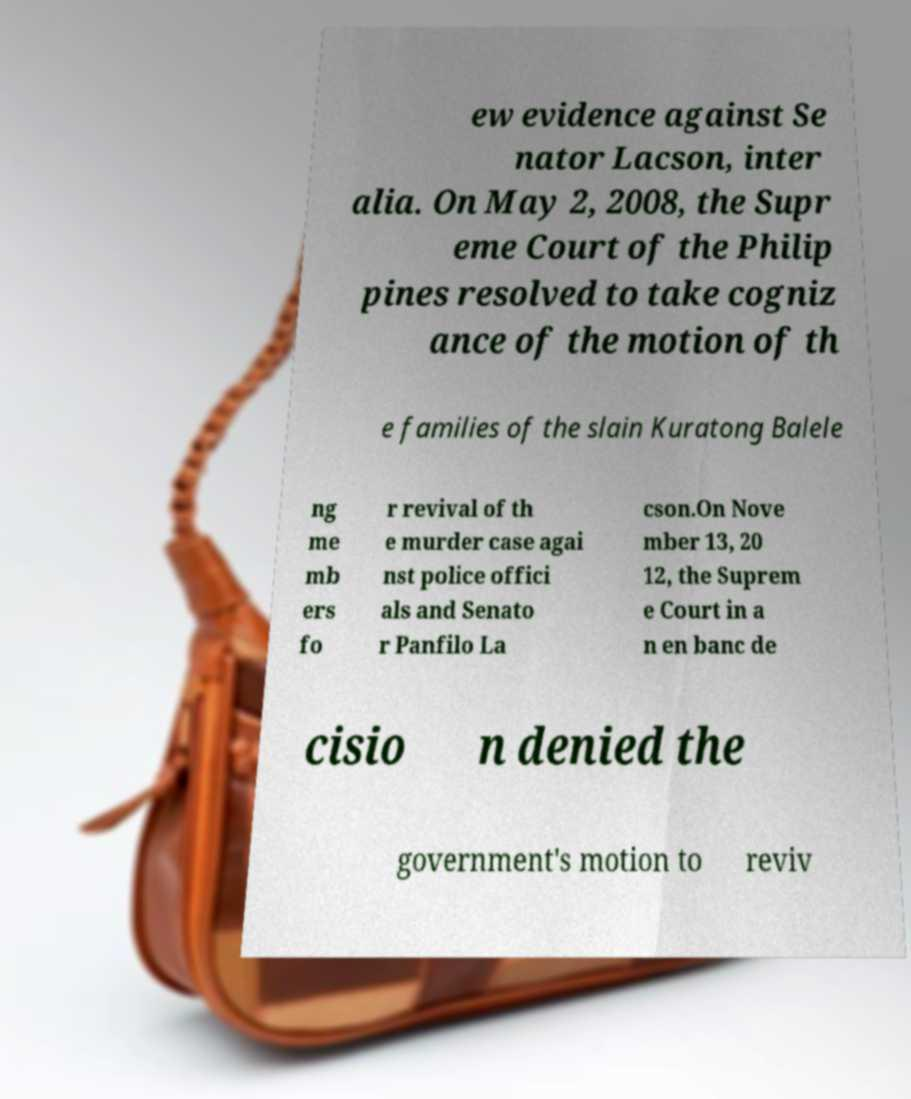Could you extract and type out the text from this image? ew evidence against Se nator Lacson, inter alia. On May 2, 2008, the Supr eme Court of the Philip pines resolved to take cogniz ance of the motion of th e families of the slain Kuratong Balele ng me mb ers fo r revival of th e murder case agai nst police offici als and Senato r Panfilo La cson.On Nove mber 13, 20 12, the Suprem e Court in a n en banc de cisio n denied the government's motion to reviv 